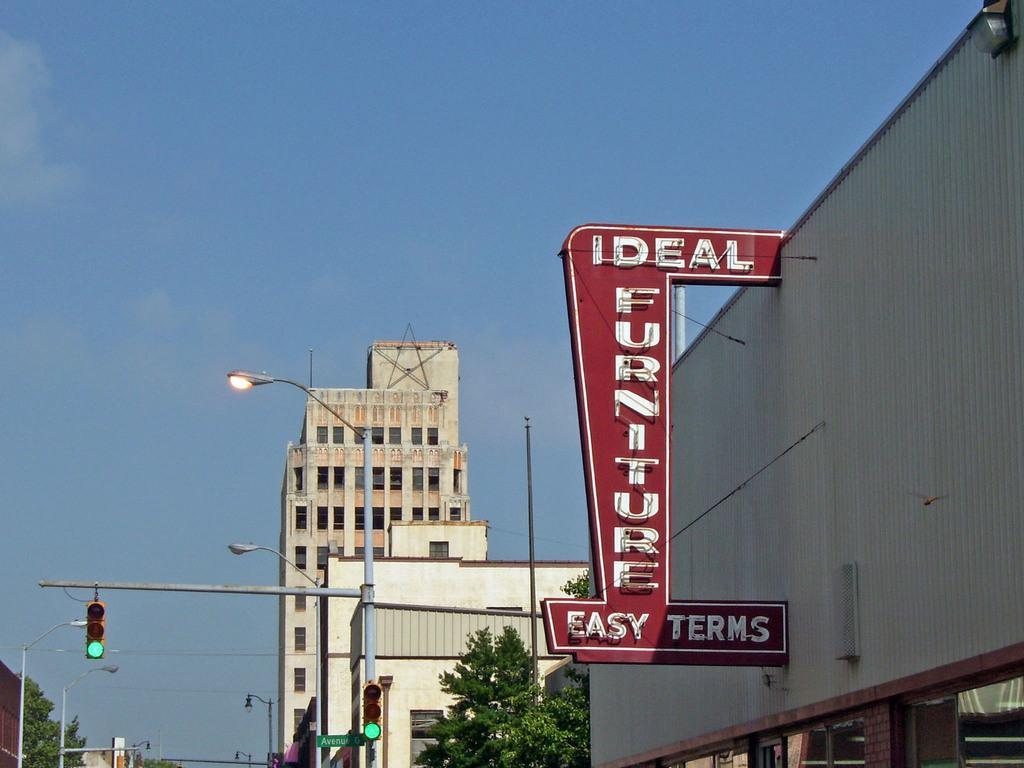What type of objects are on poles in the image? There are traffic signals and street lights on poles in the image. What type of vegetation can be seen in the image? There are trees visible in the image. What type of structures are present in the image? There are buildings in the image. What type of signs are present in the image? There is text on boards in the image. What else can be seen in the image besides the mentioned objects? There are other objects in the image. What is visible in the sky in the image? The sky is visible in the image. How does friction affect the movement of the boats in the image? There are no boats present in the image, so friction does not affect their movement. What type of cover is used to protect the trees in the image? There is no cover visible on the trees in the image. 